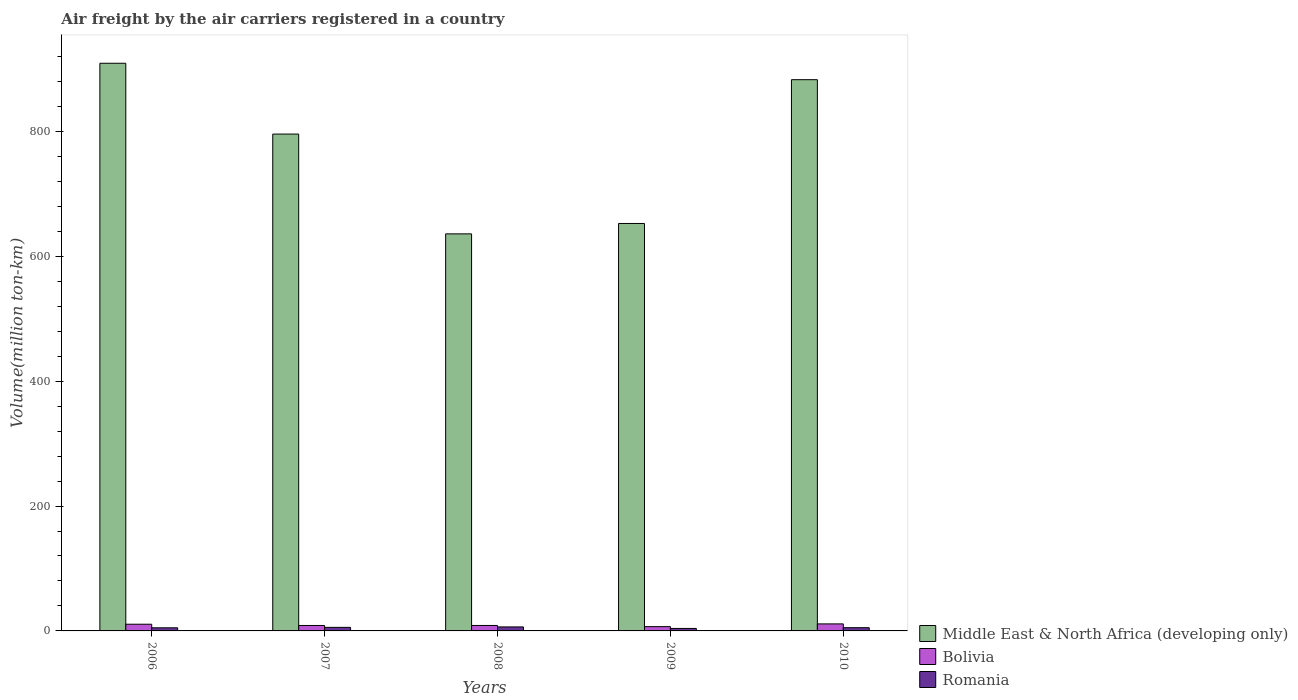Are the number of bars per tick equal to the number of legend labels?
Make the answer very short. Yes. What is the label of the 1st group of bars from the left?
Offer a terse response. 2006. In how many cases, is the number of bars for a given year not equal to the number of legend labels?
Provide a short and direct response. 0. What is the volume of the air carriers in Middle East & North Africa (developing only) in 2009?
Your answer should be compact. 652.52. Across all years, what is the maximum volume of the air carriers in Middle East & North Africa (developing only)?
Offer a terse response. 909.12. Across all years, what is the minimum volume of the air carriers in Romania?
Keep it short and to the point. 3.99. In which year was the volume of the air carriers in Bolivia maximum?
Provide a succinct answer. 2010. In which year was the volume of the air carriers in Bolivia minimum?
Give a very brief answer. 2009. What is the total volume of the air carriers in Middle East & North Africa (developing only) in the graph?
Your answer should be very brief. 3876.07. What is the difference between the volume of the air carriers in Middle East & North Africa (developing only) in 2006 and that in 2010?
Ensure brevity in your answer.  26.3. What is the difference between the volume of the air carriers in Middle East & North Africa (developing only) in 2007 and the volume of the air carriers in Bolivia in 2006?
Make the answer very short. 785. What is the average volume of the air carriers in Romania per year?
Your answer should be very brief. 5.25. In the year 2010, what is the difference between the volume of the air carriers in Bolivia and volume of the air carriers in Romania?
Provide a short and direct response. 6.07. In how many years, is the volume of the air carriers in Bolivia greater than 280 million ton-km?
Your answer should be compact. 0. What is the ratio of the volume of the air carriers in Bolivia in 2009 to that in 2010?
Your answer should be compact. 0.61. What is the difference between the highest and the second highest volume of the air carriers in Middle East & North Africa (developing only)?
Offer a terse response. 26.3. What is the difference between the highest and the lowest volume of the air carriers in Romania?
Ensure brevity in your answer.  2.43. In how many years, is the volume of the air carriers in Bolivia greater than the average volume of the air carriers in Bolivia taken over all years?
Give a very brief answer. 2. Is the sum of the volume of the air carriers in Middle East & North Africa (developing only) in 2006 and 2007 greater than the maximum volume of the air carriers in Romania across all years?
Ensure brevity in your answer.  Yes. What does the 1st bar from the left in 2010 represents?
Provide a succinct answer. Middle East & North Africa (developing only). What does the 3rd bar from the right in 2008 represents?
Your response must be concise. Middle East & North Africa (developing only). Is it the case that in every year, the sum of the volume of the air carriers in Middle East & North Africa (developing only) and volume of the air carriers in Bolivia is greater than the volume of the air carriers in Romania?
Offer a terse response. Yes. How many bars are there?
Make the answer very short. 15. Are the values on the major ticks of Y-axis written in scientific E-notation?
Provide a succinct answer. No. Does the graph contain any zero values?
Offer a very short reply. No. How many legend labels are there?
Your response must be concise. 3. How are the legend labels stacked?
Your answer should be very brief. Vertical. What is the title of the graph?
Give a very brief answer. Air freight by the air carriers registered in a country. Does "Guatemala" appear as one of the legend labels in the graph?
Keep it short and to the point. No. What is the label or title of the X-axis?
Offer a terse response. Years. What is the label or title of the Y-axis?
Provide a short and direct response. Volume(million ton-km). What is the Volume(million ton-km) of Middle East & North Africa (developing only) in 2006?
Your response must be concise. 909.12. What is the Volume(million ton-km) of Bolivia in 2006?
Make the answer very short. 10.71. What is the Volume(million ton-km) in Romania in 2006?
Your response must be concise. 4.98. What is the Volume(million ton-km) of Middle East & North Africa (developing only) in 2007?
Provide a succinct answer. 795.72. What is the Volume(million ton-km) of Bolivia in 2007?
Your answer should be compact. 8.72. What is the Volume(million ton-km) of Romania in 2007?
Provide a short and direct response. 5.68. What is the Volume(million ton-km) of Middle East & North Africa (developing only) in 2008?
Provide a short and direct response. 635.89. What is the Volume(million ton-km) in Bolivia in 2008?
Give a very brief answer. 8.76. What is the Volume(million ton-km) in Romania in 2008?
Your answer should be very brief. 6.42. What is the Volume(million ton-km) of Middle East & North Africa (developing only) in 2009?
Your response must be concise. 652.52. What is the Volume(million ton-km) of Bolivia in 2009?
Offer a terse response. 6.87. What is the Volume(million ton-km) in Romania in 2009?
Make the answer very short. 3.99. What is the Volume(million ton-km) in Middle East & North Africa (developing only) in 2010?
Offer a terse response. 882.82. What is the Volume(million ton-km) in Bolivia in 2010?
Make the answer very short. 11.24. What is the Volume(million ton-km) in Romania in 2010?
Offer a very short reply. 5.16. Across all years, what is the maximum Volume(million ton-km) of Middle East & North Africa (developing only)?
Provide a short and direct response. 909.12. Across all years, what is the maximum Volume(million ton-km) of Bolivia?
Provide a short and direct response. 11.24. Across all years, what is the maximum Volume(million ton-km) of Romania?
Offer a very short reply. 6.42. Across all years, what is the minimum Volume(million ton-km) in Middle East & North Africa (developing only)?
Offer a terse response. 635.89. Across all years, what is the minimum Volume(million ton-km) in Bolivia?
Offer a terse response. 6.87. Across all years, what is the minimum Volume(million ton-km) in Romania?
Offer a terse response. 3.99. What is the total Volume(million ton-km) of Middle East & North Africa (developing only) in the graph?
Your response must be concise. 3876.07. What is the total Volume(million ton-km) of Bolivia in the graph?
Ensure brevity in your answer.  46.29. What is the total Volume(million ton-km) in Romania in the graph?
Provide a short and direct response. 26.24. What is the difference between the Volume(million ton-km) in Middle East & North Africa (developing only) in 2006 and that in 2007?
Provide a succinct answer. 113.4. What is the difference between the Volume(million ton-km) of Bolivia in 2006 and that in 2007?
Keep it short and to the point. 2. What is the difference between the Volume(million ton-km) of Romania in 2006 and that in 2007?
Ensure brevity in your answer.  -0.7. What is the difference between the Volume(million ton-km) of Middle East & North Africa (developing only) in 2006 and that in 2008?
Keep it short and to the point. 273.22. What is the difference between the Volume(million ton-km) in Bolivia in 2006 and that in 2008?
Offer a very short reply. 1.96. What is the difference between the Volume(million ton-km) in Romania in 2006 and that in 2008?
Offer a terse response. -1.44. What is the difference between the Volume(million ton-km) in Middle East & North Africa (developing only) in 2006 and that in 2009?
Provide a succinct answer. 256.6. What is the difference between the Volume(million ton-km) in Bolivia in 2006 and that in 2009?
Ensure brevity in your answer.  3.84. What is the difference between the Volume(million ton-km) in Romania in 2006 and that in 2009?
Ensure brevity in your answer.  1. What is the difference between the Volume(million ton-km) of Middle East & North Africa (developing only) in 2006 and that in 2010?
Make the answer very short. 26.3. What is the difference between the Volume(million ton-km) of Bolivia in 2006 and that in 2010?
Ensure brevity in your answer.  -0.52. What is the difference between the Volume(million ton-km) in Romania in 2006 and that in 2010?
Ensure brevity in your answer.  -0.18. What is the difference between the Volume(million ton-km) in Middle East & North Africa (developing only) in 2007 and that in 2008?
Provide a succinct answer. 159.82. What is the difference between the Volume(million ton-km) of Bolivia in 2007 and that in 2008?
Your answer should be very brief. -0.04. What is the difference between the Volume(million ton-km) in Romania in 2007 and that in 2008?
Offer a terse response. -0.74. What is the difference between the Volume(million ton-km) of Middle East & North Africa (developing only) in 2007 and that in 2009?
Your response must be concise. 143.19. What is the difference between the Volume(million ton-km) of Bolivia in 2007 and that in 2009?
Offer a terse response. 1.85. What is the difference between the Volume(million ton-km) in Romania in 2007 and that in 2009?
Keep it short and to the point. 1.7. What is the difference between the Volume(million ton-km) of Middle East & North Africa (developing only) in 2007 and that in 2010?
Make the answer very short. -87.1. What is the difference between the Volume(million ton-km) of Bolivia in 2007 and that in 2010?
Provide a short and direct response. -2.52. What is the difference between the Volume(million ton-km) of Romania in 2007 and that in 2010?
Make the answer very short. 0.52. What is the difference between the Volume(million ton-km) of Middle East & North Africa (developing only) in 2008 and that in 2009?
Your answer should be compact. -16.63. What is the difference between the Volume(million ton-km) in Bolivia in 2008 and that in 2009?
Provide a succinct answer. 1.88. What is the difference between the Volume(million ton-km) in Romania in 2008 and that in 2009?
Offer a terse response. 2.43. What is the difference between the Volume(million ton-km) of Middle East & North Africa (developing only) in 2008 and that in 2010?
Provide a succinct answer. -246.92. What is the difference between the Volume(million ton-km) of Bolivia in 2008 and that in 2010?
Make the answer very short. -2.48. What is the difference between the Volume(million ton-km) in Romania in 2008 and that in 2010?
Offer a very short reply. 1.26. What is the difference between the Volume(million ton-km) in Middle East & North Africa (developing only) in 2009 and that in 2010?
Give a very brief answer. -230.29. What is the difference between the Volume(million ton-km) in Bolivia in 2009 and that in 2010?
Ensure brevity in your answer.  -4.37. What is the difference between the Volume(million ton-km) of Romania in 2009 and that in 2010?
Your answer should be very brief. -1.18. What is the difference between the Volume(million ton-km) of Middle East & North Africa (developing only) in 2006 and the Volume(million ton-km) of Bolivia in 2007?
Offer a terse response. 900.4. What is the difference between the Volume(million ton-km) of Middle East & North Africa (developing only) in 2006 and the Volume(million ton-km) of Romania in 2007?
Your answer should be very brief. 903.43. What is the difference between the Volume(million ton-km) in Bolivia in 2006 and the Volume(million ton-km) in Romania in 2007?
Your answer should be very brief. 5.03. What is the difference between the Volume(million ton-km) in Middle East & North Africa (developing only) in 2006 and the Volume(million ton-km) in Bolivia in 2008?
Provide a short and direct response. 900.36. What is the difference between the Volume(million ton-km) in Middle East & North Africa (developing only) in 2006 and the Volume(million ton-km) in Romania in 2008?
Offer a very short reply. 902.7. What is the difference between the Volume(million ton-km) in Bolivia in 2006 and the Volume(million ton-km) in Romania in 2008?
Your response must be concise. 4.29. What is the difference between the Volume(million ton-km) in Middle East & North Africa (developing only) in 2006 and the Volume(million ton-km) in Bolivia in 2009?
Your answer should be very brief. 902.25. What is the difference between the Volume(million ton-km) in Middle East & North Africa (developing only) in 2006 and the Volume(million ton-km) in Romania in 2009?
Your answer should be compact. 905.13. What is the difference between the Volume(million ton-km) in Bolivia in 2006 and the Volume(million ton-km) in Romania in 2009?
Keep it short and to the point. 6.73. What is the difference between the Volume(million ton-km) in Middle East & North Africa (developing only) in 2006 and the Volume(million ton-km) in Bolivia in 2010?
Make the answer very short. 897.88. What is the difference between the Volume(million ton-km) in Middle East & North Africa (developing only) in 2006 and the Volume(million ton-km) in Romania in 2010?
Provide a succinct answer. 903.96. What is the difference between the Volume(million ton-km) in Bolivia in 2006 and the Volume(million ton-km) in Romania in 2010?
Make the answer very short. 5.55. What is the difference between the Volume(million ton-km) in Middle East & North Africa (developing only) in 2007 and the Volume(million ton-km) in Bolivia in 2008?
Provide a succinct answer. 786.96. What is the difference between the Volume(million ton-km) of Middle East & North Africa (developing only) in 2007 and the Volume(million ton-km) of Romania in 2008?
Offer a terse response. 789.3. What is the difference between the Volume(million ton-km) in Bolivia in 2007 and the Volume(million ton-km) in Romania in 2008?
Offer a very short reply. 2.3. What is the difference between the Volume(million ton-km) in Middle East & North Africa (developing only) in 2007 and the Volume(million ton-km) in Bolivia in 2009?
Keep it short and to the point. 788.85. What is the difference between the Volume(million ton-km) in Middle East & North Africa (developing only) in 2007 and the Volume(million ton-km) in Romania in 2009?
Your answer should be very brief. 791.73. What is the difference between the Volume(million ton-km) of Bolivia in 2007 and the Volume(million ton-km) of Romania in 2009?
Offer a very short reply. 4.73. What is the difference between the Volume(million ton-km) of Middle East & North Africa (developing only) in 2007 and the Volume(million ton-km) of Bolivia in 2010?
Offer a very short reply. 784.48. What is the difference between the Volume(million ton-km) of Middle East & North Africa (developing only) in 2007 and the Volume(million ton-km) of Romania in 2010?
Provide a short and direct response. 790.55. What is the difference between the Volume(million ton-km) of Bolivia in 2007 and the Volume(million ton-km) of Romania in 2010?
Ensure brevity in your answer.  3.55. What is the difference between the Volume(million ton-km) of Middle East & North Africa (developing only) in 2008 and the Volume(million ton-km) of Bolivia in 2009?
Offer a very short reply. 629.02. What is the difference between the Volume(million ton-km) of Middle East & North Africa (developing only) in 2008 and the Volume(million ton-km) of Romania in 2009?
Provide a short and direct response. 631.91. What is the difference between the Volume(million ton-km) of Bolivia in 2008 and the Volume(million ton-km) of Romania in 2009?
Your answer should be very brief. 4.77. What is the difference between the Volume(million ton-km) in Middle East & North Africa (developing only) in 2008 and the Volume(million ton-km) in Bolivia in 2010?
Your answer should be very brief. 624.66. What is the difference between the Volume(million ton-km) of Middle East & North Africa (developing only) in 2008 and the Volume(million ton-km) of Romania in 2010?
Give a very brief answer. 630.73. What is the difference between the Volume(million ton-km) in Bolivia in 2008 and the Volume(million ton-km) in Romania in 2010?
Your answer should be very brief. 3.59. What is the difference between the Volume(million ton-km) of Middle East & North Africa (developing only) in 2009 and the Volume(million ton-km) of Bolivia in 2010?
Make the answer very short. 641.29. What is the difference between the Volume(million ton-km) in Middle East & North Africa (developing only) in 2009 and the Volume(million ton-km) in Romania in 2010?
Make the answer very short. 647.36. What is the difference between the Volume(million ton-km) of Bolivia in 2009 and the Volume(million ton-km) of Romania in 2010?
Provide a short and direct response. 1.71. What is the average Volume(million ton-km) of Middle East & North Africa (developing only) per year?
Your response must be concise. 775.21. What is the average Volume(million ton-km) of Bolivia per year?
Keep it short and to the point. 9.26. What is the average Volume(million ton-km) of Romania per year?
Your answer should be very brief. 5.25. In the year 2006, what is the difference between the Volume(million ton-km) in Middle East & North Africa (developing only) and Volume(million ton-km) in Bolivia?
Provide a succinct answer. 898.4. In the year 2006, what is the difference between the Volume(million ton-km) in Middle East & North Africa (developing only) and Volume(million ton-km) in Romania?
Your answer should be compact. 904.13. In the year 2006, what is the difference between the Volume(million ton-km) in Bolivia and Volume(million ton-km) in Romania?
Your response must be concise. 5.73. In the year 2007, what is the difference between the Volume(million ton-km) of Middle East & North Africa (developing only) and Volume(million ton-km) of Bolivia?
Make the answer very short. 787. In the year 2007, what is the difference between the Volume(million ton-km) in Middle East & North Africa (developing only) and Volume(million ton-km) in Romania?
Offer a terse response. 790.03. In the year 2007, what is the difference between the Volume(million ton-km) of Bolivia and Volume(million ton-km) of Romania?
Offer a very short reply. 3.03. In the year 2008, what is the difference between the Volume(million ton-km) of Middle East & North Africa (developing only) and Volume(million ton-km) of Bolivia?
Keep it short and to the point. 627.14. In the year 2008, what is the difference between the Volume(million ton-km) of Middle East & North Africa (developing only) and Volume(million ton-km) of Romania?
Offer a terse response. 629.47. In the year 2008, what is the difference between the Volume(million ton-km) in Bolivia and Volume(million ton-km) in Romania?
Your response must be concise. 2.33. In the year 2009, what is the difference between the Volume(million ton-km) of Middle East & North Africa (developing only) and Volume(million ton-km) of Bolivia?
Offer a very short reply. 645.65. In the year 2009, what is the difference between the Volume(million ton-km) of Middle East & North Africa (developing only) and Volume(million ton-km) of Romania?
Give a very brief answer. 648.53. In the year 2009, what is the difference between the Volume(million ton-km) of Bolivia and Volume(million ton-km) of Romania?
Your answer should be very brief. 2.88. In the year 2010, what is the difference between the Volume(million ton-km) of Middle East & North Africa (developing only) and Volume(million ton-km) of Bolivia?
Keep it short and to the point. 871.58. In the year 2010, what is the difference between the Volume(million ton-km) of Middle East & North Africa (developing only) and Volume(million ton-km) of Romania?
Offer a very short reply. 877.65. In the year 2010, what is the difference between the Volume(million ton-km) of Bolivia and Volume(million ton-km) of Romania?
Provide a short and direct response. 6.07. What is the ratio of the Volume(million ton-km) in Middle East & North Africa (developing only) in 2006 to that in 2007?
Keep it short and to the point. 1.14. What is the ratio of the Volume(million ton-km) of Bolivia in 2006 to that in 2007?
Your answer should be compact. 1.23. What is the ratio of the Volume(million ton-km) in Romania in 2006 to that in 2007?
Provide a short and direct response. 0.88. What is the ratio of the Volume(million ton-km) in Middle East & North Africa (developing only) in 2006 to that in 2008?
Offer a very short reply. 1.43. What is the ratio of the Volume(million ton-km) in Bolivia in 2006 to that in 2008?
Keep it short and to the point. 1.22. What is the ratio of the Volume(million ton-km) in Romania in 2006 to that in 2008?
Give a very brief answer. 0.78. What is the ratio of the Volume(million ton-km) of Middle East & North Africa (developing only) in 2006 to that in 2009?
Keep it short and to the point. 1.39. What is the ratio of the Volume(million ton-km) of Bolivia in 2006 to that in 2009?
Ensure brevity in your answer.  1.56. What is the ratio of the Volume(million ton-km) of Romania in 2006 to that in 2009?
Your answer should be compact. 1.25. What is the ratio of the Volume(million ton-km) of Middle East & North Africa (developing only) in 2006 to that in 2010?
Offer a very short reply. 1.03. What is the ratio of the Volume(million ton-km) of Bolivia in 2006 to that in 2010?
Make the answer very short. 0.95. What is the ratio of the Volume(million ton-km) of Romania in 2006 to that in 2010?
Offer a terse response. 0.97. What is the ratio of the Volume(million ton-km) in Middle East & North Africa (developing only) in 2007 to that in 2008?
Make the answer very short. 1.25. What is the ratio of the Volume(million ton-km) of Romania in 2007 to that in 2008?
Ensure brevity in your answer.  0.89. What is the ratio of the Volume(million ton-km) of Middle East & North Africa (developing only) in 2007 to that in 2009?
Provide a succinct answer. 1.22. What is the ratio of the Volume(million ton-km) of Bolivia in 2007 to that in 2009?
Provide a short and direct response. 1.27. What is the ratio of the Volume(million ton-km) of Romania in 2007 to that in 2009?
Ensure brevity in your answer.  1.43. What is the ratio of the Volume(million ton-km) in Middle East & North Africa (developing only) in 2007 to that in 2010?
Ensure brevity in your answer.  0.9. What is the ratio of the Volume(million ton-km) in Bolivia in 2007 to that in 2010?
Your response must be concise. 0.78. What is the ratio of the Volume(million ton-km) of Romania in 2007 to that in 2010?
Give a very brief answer. 1.1. What is the ratio of the Volume(million ton-km) of Middle East & North Africa (developing only) in 2008 to that in 2009?
Offer a very short reply. 0.97. What is the ratio of the Volume(million ton-km) in Bolivia in 2008 to that in 2009?
Offer a very short reply. 1.27. What is the ratio of the Volume(million ton-km) in Romania in 2008 to that in 2009?
Ensure brevity in your answer.  1.61. What is the ratio of the Volume(million ton-km) in Middle East & North Africa (developing only) in 2008 to that in 2010?
Keep it short and to the point. 0.72. What is the ratio of the Volume(million ton-km) of Bolivia in 2008 to that in 2010?
Offer a very short reply. 0.78. What is the ratio of the Volume(million ton-km) of Romania in 2008 to that in 2010?
Ensure brevity in your answer.  1.24. What is the ratio of the Volume(million ton-km) of Middle East & North Africa (developing only) in 2009 to that in 2010?
Keep it short and to the point. 0.74. What is the ratio of the Volume(million ton-km) in Bolivia in 2009 to that in 2010?
Provide a succinct answer. 0.61. What is the ratio of the Volume(million ton-km) of Romania in 2009 to that in 2010?
Give a very brief answer. 0.77. What is the difference between the highest and the second highest Volume(million ton-km) in Middle East & North Africa (developing only)?
Offer a terse response. 26.3. What is the difference between the highest and the second highest Volume(million ton-km) in Bolivia?
Ensure brevity in your answer.  0.52. What is the difference between the highest and the second highest Volume(million ton-km) in Romania?
Your response must be concise. 0.74. What is the difference between the highest and the lowest Volume(million ton-km) of Middle East & North Africa (developing only)?
Your answer should be compact. 273.22. What is the difference between the highest and the lowest Volume(million ton-km) in Bolivia?
Provide a short and direct response. 4.37. What is the difference between the highest and the lowest Volume(million ton-km) of Romania?
Give a very brief answer. 2.43. 